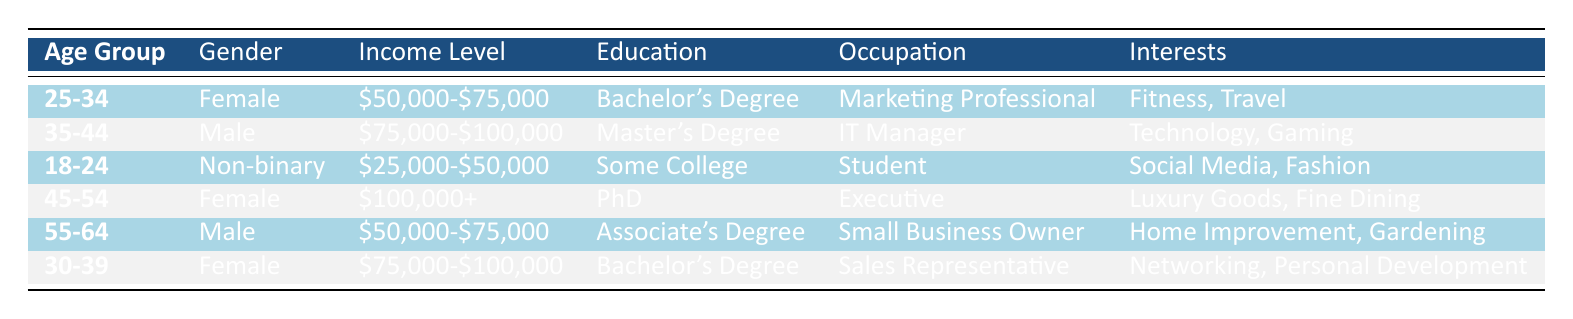What is the income level of the youngest age group? The youngest age group is 18-24, and according to the table, their income level is between $25,000 and $50,000.
Answer: $25,000-$50,000 How many females are listed in the table? The table shows two females: one in the age group 25-34 and the other in 45-54.
Answer: 2 What are the interests of individuals in the 30-39 age group? The table indicates that individuals in the 30-39 age group are interested in networking and personal development.
Answer: Networking, Personal Development Is there a male in the table with a PhD? The table shows that the only individual with a PhD is a female in the 45-54 age group, thus there is no male with a PhD.
Answer: No What is the average income level of all individuals listed in the table? To find the average income, we assess the income ranges: $62,500 (midpoint of $50,000-$75,000) for two groups, $87,500 (midpoint of $75,000-$100,000), and $100,000+ (considered as $100,000 for averaging) for one group. Adding these incomes yields $62,500 + $87,500 + $100,000 + $100,000 + $62,500 + $87,500 = $500,000. We then divide this total by 6 individuals, resulting in an average income of approximately $83,333.
Answer: $83,333 Which age group has the highest income level? The highest income level is observed for the 45-54 age group, where the individual earns over $100,000.
Answer: 45-54 